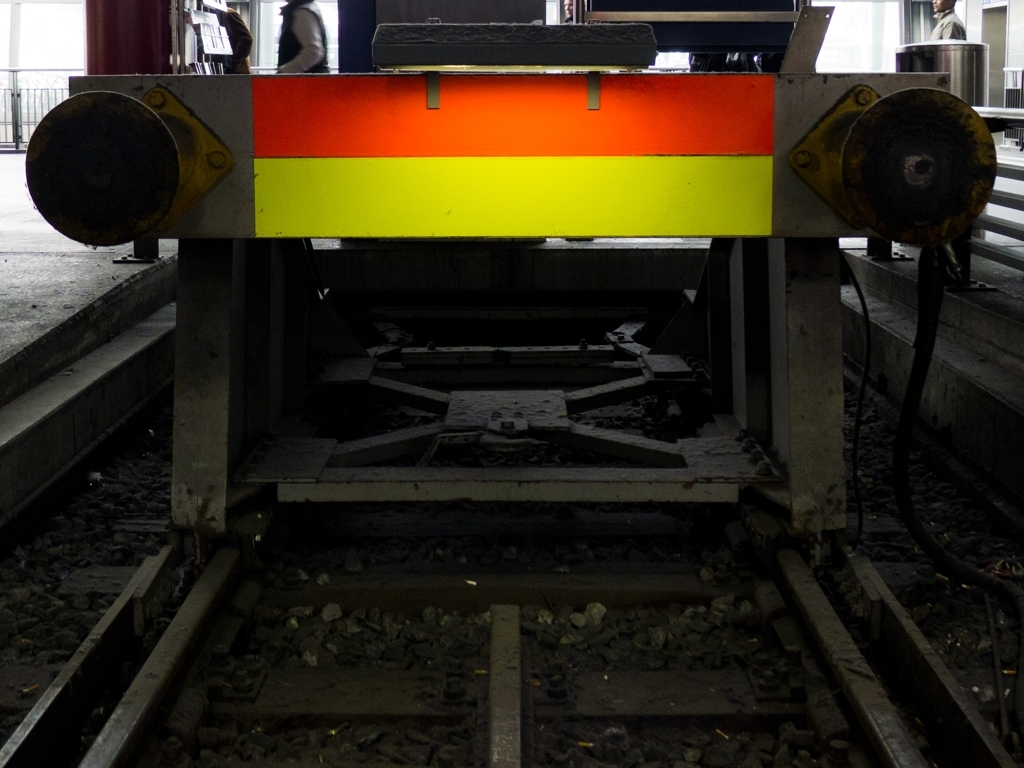Is this location commonly accessed by the public, or does it seem more industrial and restricted in nature? Based on the image, this location appears to be more industrial and potentially restricted in nature. The design and condition of the track, lack of pedestrian amenities, and the surrounding infrastructure all indicate an environment primarily designed for operational or service use rather than public access. 